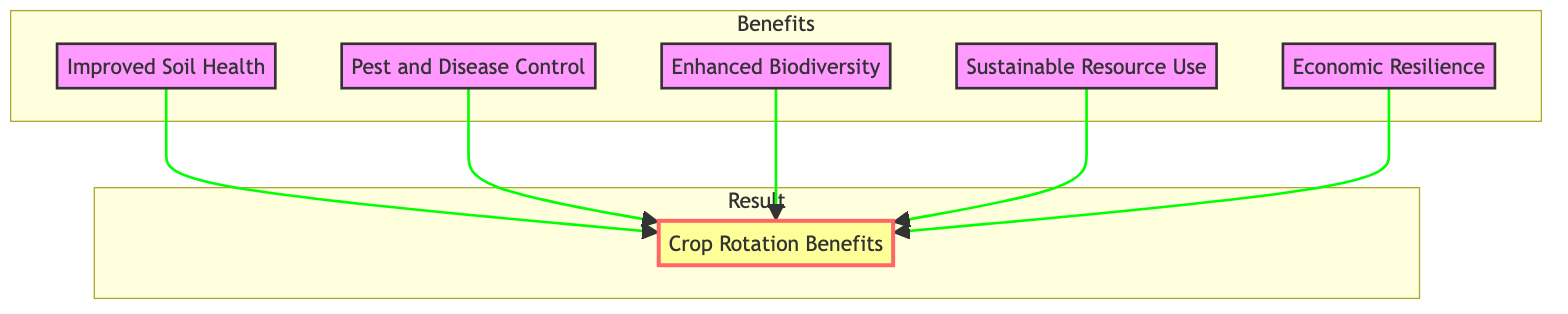What are the main benefits of crop rotation listed in the diagram? The diagram lists five benefits: Improved Soil Health, Pest and Disease Control, Enhanced Biodiversity, Sustainable Resource Use, and Economic Resilience.
Answer: Improved Soil Health, Pest and Disease Control, Enhanced Biodiversity, Sustainable Resource Use, Economic Resilience How many benefits are shown in the diagram? Counting the benefits listed under the "Benefits" subgraph, there are a total of five benefits shown in the diagram.
Answer: 5 Which benefit relates to the use of chemical pesticides? The benefit related to the use of chemical pesticides is "Pest and Disease Control," as it states that crop rotation disrupts pest and disease cycles and reduces the need for chemical pesticides.
Answer: Pest and Disease Control Which benefit emphasizes the optimization of resource use? The benefit that emphasizes the optimization of resource use is "Sustainable Resource Use," which indicates that crop rotation minimizes the depletion of available water and nutrients.
Answer: Sustainable Resource Use How does "Enhanced Biodiversity" contribute to ecosystem resilience? "Enhanced Biodiversity" contributes to ecosystem resilience by fostering a variety of soil organisms, which helps create balanced ecosystems and boosts the farm's ability to withstand challenges.
Answer: Fosters a variety of soil organisms What is the relationship between all benefits and crop rotation? All benefits are connected to "Crop Rotation Benefits," which is the main result node in the diagram and shows that these benefits arise from practicing crop rotation.
Answer: All contribute to Crop Rotation Benefits What is the central outcome of implementing the benefits of crop rotation? The central outcome of implementing the benefits of crop rotation is encapsulated in the node "Crop Rotation Benefits," which indicates the overarching result of applying improved practices.
Answer: Crop Rotation Benefits 